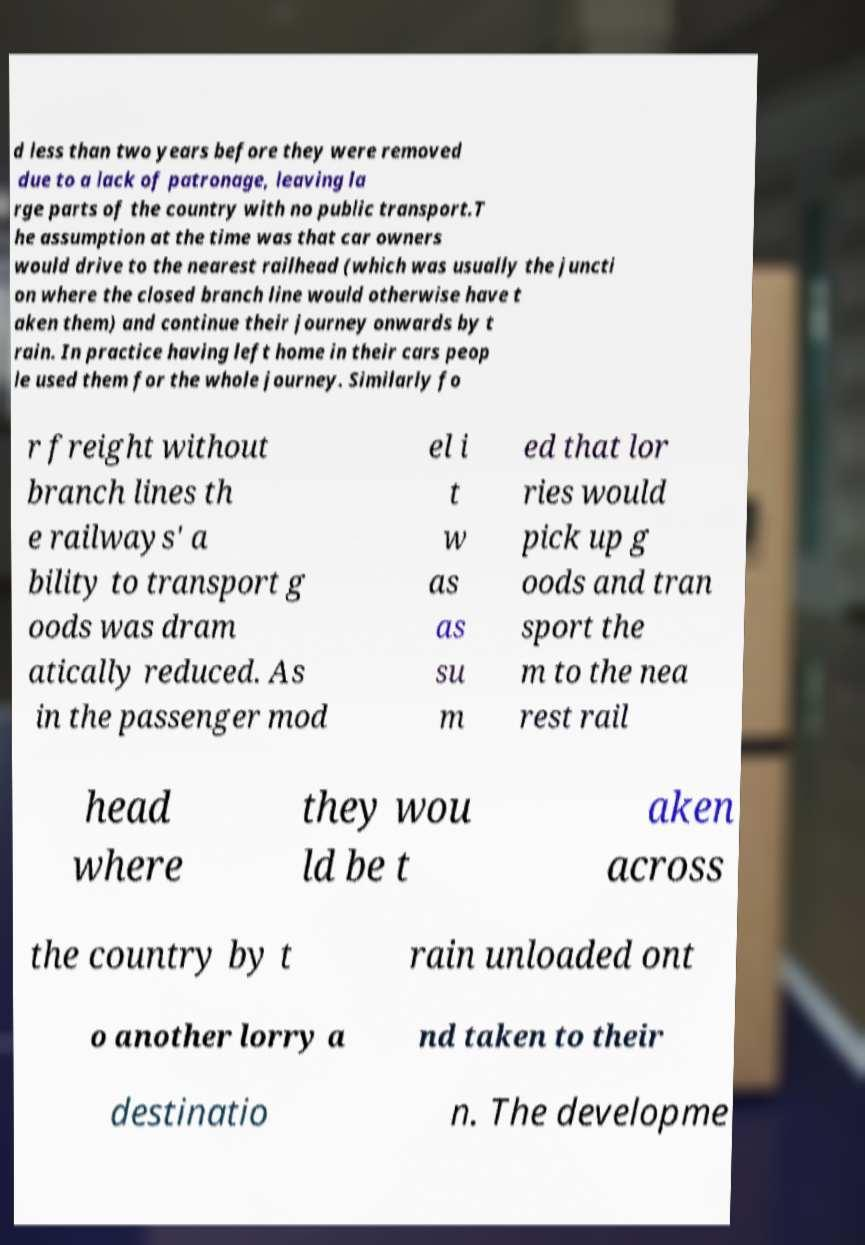Can you accurately transcribe the text from the provided image for me? d less than two years before they were removed due to a lack of patronage, leaving la rge parts of the country with no public transport.T he assumption at the time was that car owners would drive to the nearest railhead (which was usually the juncti on where the closed branch line would otherwise have t aken them) and continue their journey onwards by t rain. In practice having left home in their cars peop le used them for the whole journey. Similarly fo r freight without branch lines th e railways' a bility to transport g oods was dram atically reduced. As in the passenger mod el i t w as as su m ed that lor ries would pick up g oods and tran sport the m to the nea rest rail head where they wou ld be t aken across the country by t rain unloaded ont o another lorry a nd taken to their destinatio n. The developme 